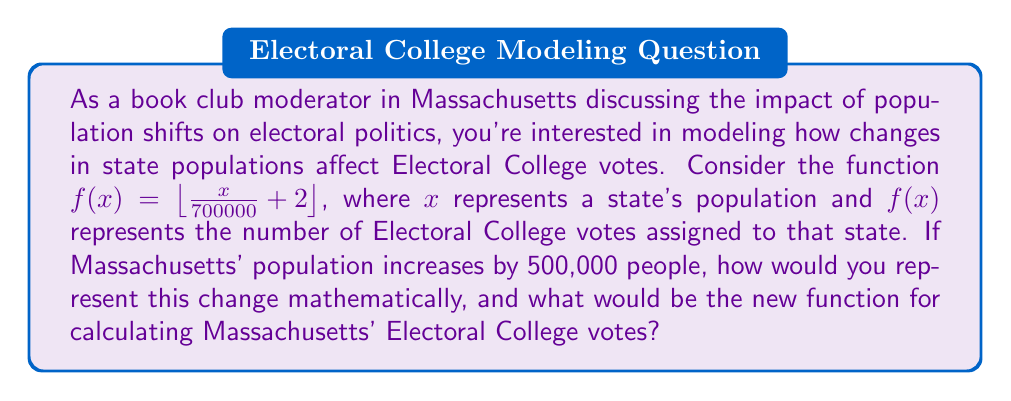Show me your answer to this math problem. To solve this problem, we need to understand function translations and how they apply to the given scenario:

1) The original function is $f(x) = \lfloor \frac{x}{700000} + 2 \rfloor$, where:
   - $x$ is the state's population
   - The fraction $\frac{x}{700000}$ represents the number of representatives based on population
   - The $+2$ accounts for the two senators each state has
   - The floor function $\lfloor \rfloor$ ensures we get a whole number of electoral votes

2) An increase in population by 500,000 people can be represented as a horizontal shift of the function to the left by 500,000 units.

3) For a horizontal shift to the left, we add the shift value inside the function:
   $g(x) = f(x + 500000)$

4) Substituting the original function:
   $g(x) = \lfloor \frac{(x + 500000)}{700000} + 2 \rfloor$

5) Simplifying inside the floor function:
   $g(x) = \lfloor \frac{x}{700000} + \frac{500000}{700000} + 2 \rfloor$

6) Further simplification:
   $g(x) = \lfloor \frac{x}{700000} + \frac{5}{7} + 2 \rfloor$

Therefore, the new function for calculating Massachusetts' Electoral College votes after the population increase would be:

$g(x) = \lfloor \frac{x}{700000} + 2.7142857... \rfloor$

This function will always yield a result that is either the same as or one more than the original function, depending on where the additional $\frac{5}{7}$ pushes the value relative to the next whole number.
Answer: $g(x) = \lfloor \frac{x}{700000} + 2.7142857... \rfloor$ or $g(x) = \lfloor \frac{x}{700000} + \frac{19}{7} \rfloor$ 